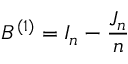Convert formula to latex. <formula><loc_0><loc_0><loc_500><loc_500>B ^ { ( 1 ) } = I _ { n } - { \frac { J _ { n } } { n } }</formula> 